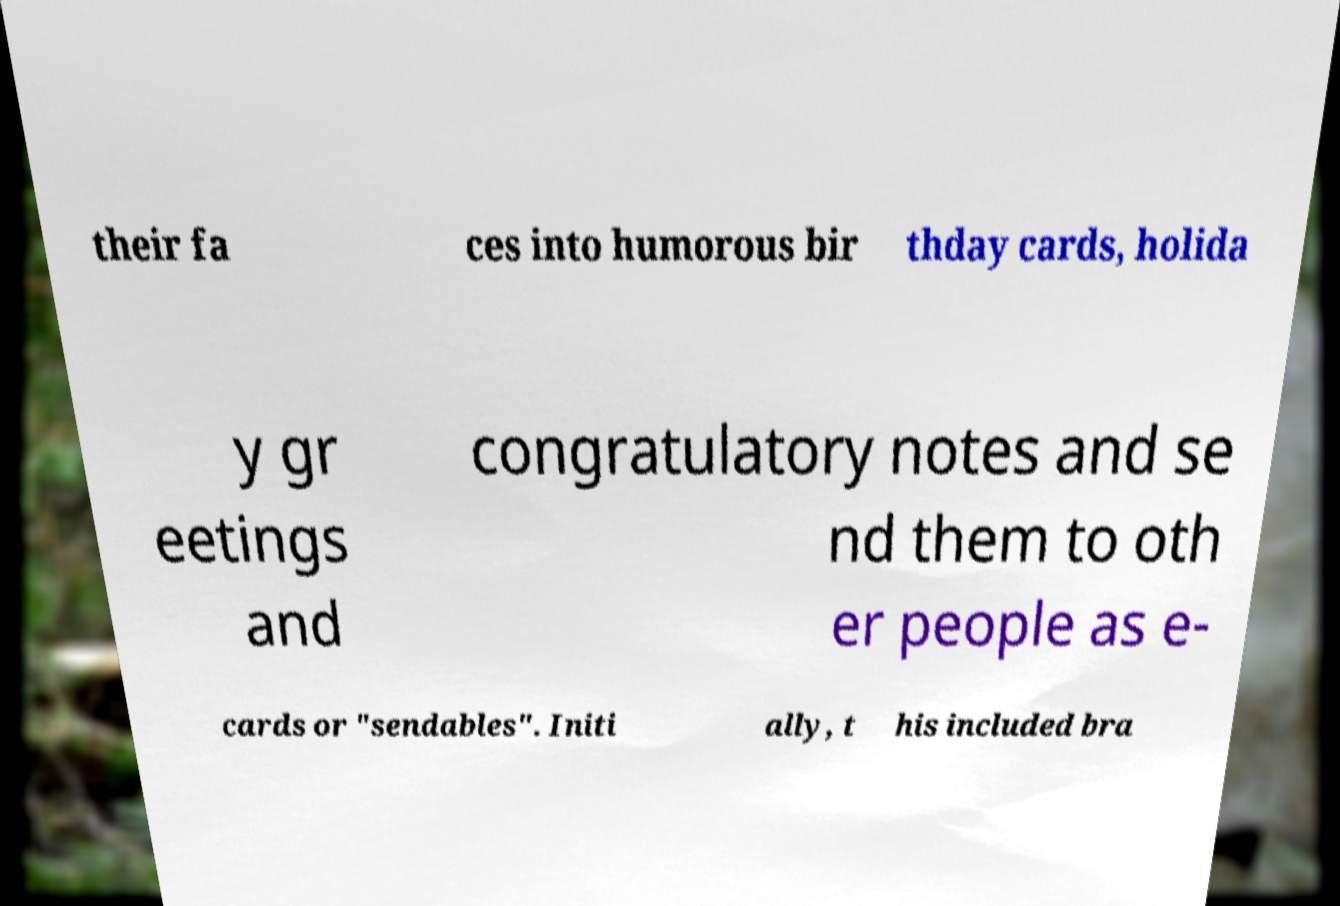I need the written content from this picture converted into text. Can you do that? their fa ces into humorous bir thday cards, holida y gr eetings and congratulatory notes and se nd them to oth er people as e- cards or "sendables". Initi ally, t his included bra 